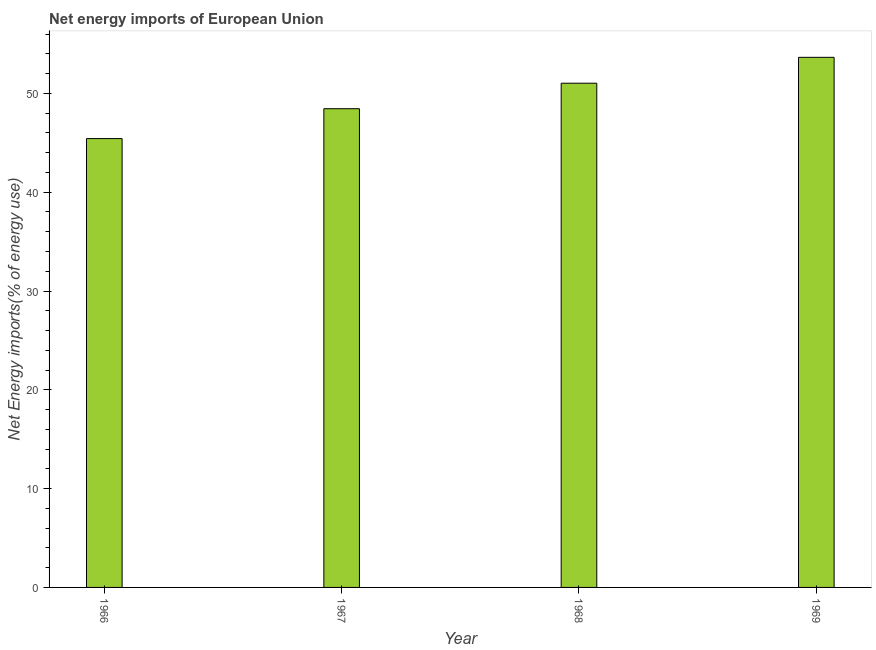What is the title of the graph?
Provide a short and direct response. Net energy imports of European Union. What is the label or title of the X-axis?
Your answer should be very brief. Year. What is the label or title of the Y-axis?
Keep it short and to the point. Net Energy imports(% of energy use). What is the energy imports in 1966?
Ensure brevity in your answer.  45.43. Across all years, what is the maximum energy imports?
Your answer should be very brief. 53.65. Across all years, what is the minimum energy imports?
Give a very brief answer. 45.43. In which year was the energy imports maximum?
Provide a succinct answer. 1969. In which year was the energy imports minimum?
Give a very brief answer. 1966. What is the sum of the energy imports?
Offer a terse response. 198.57. What is the difference between the energy imports in 1966 and 1968?
Your answer should be compact. -5.61. What is the average energy imports per year?
Your answer should be very brief. 49.64. What is the median energy imports?
Ensure brevity in your answer.  49.74. Do a majority of the years between 1966 and 1969 (inclusive) have energy imports greater than 32 %?
Your answer should be compact. Yes. What is the ratio of the energy imports in 1966 to that in 1967?
Give a very brief answer. 0.94. What is the difference between the highest and the second highest energy imports?
Your answer should be compact. 2.62. Is the sum of the energy imports in 1966 and 1967 greater than the maximum energy imports across all years?
Your response must be concise. Yes. What is the difference between the highest and the lowest energy imports?
Make the answer very short. 8.22. Are all the bars in the graph horizontal?
Offer a terse response. No. How many years are there in the graph?
Provide a short and direct response. 4. What is the difference between two consecutive major ticks on the Y-axis?
Your response must be concise. 10. Are the values on the major ticks of Y-axis written in scientific E-notation?
Give a very brief answer. No. What is the Net Energy imports(% of energy use) of 1966?
Give a very brief answer. 45.43. What is the Net Energy imports(% of energy use) in 1967?
Give a very brief answer. 48.45. What is the Net Energy imports(% of energy use) of 1968?
Your response must be concise. 51.03. What is the Net Energy imports(% of energy use) in 1969?
Keep it short and to the point. 53.65. What is the difference between the Net Energy imports(% of energy use) in 1966 and 1967?
Offer a very short reply. -3.02. What is the difference between the Net Energy imports(% of energy use) in 1966 and 1968?
Your response must be concise. -5.61. What is the difference between the Net Energy imports(% of energy use) in 1966 and 1969?
Your answer should be very brief. -8.22. What is the difference between the Net Energy imports(% of energy use) in 1967 and 1968?
Ensure brevity in your answer.  -2.58. What is the difference between the Net Energy imports(% of energy use) in 1967 and 1969?
Keep it short and to the point. -5.2. What is the difference between the Net Energy imports(% of energy use) in 1968 and 1969?
Your answer should be very brief. -2.62. What is the ratio of the Net Energy imports(% of energy use) in 1966 to that in 1967?
Your response must be concise. 0.94. What is the ratio of the Net Energy imports(% of energy use) in 1966 to that in 1968?
Keep it short and to the point. 0.89. What is the ratio of the Net Energy imports(% of energy use) in 1966 to that in 1969?
Offer a terse response. 0.85. What is the ratio of the Net Energy imports(% of energy use) in 1967 to that in 1968?
Keep it short and to the point. 0.95. What is the ratio of the Net Energy imports(% of energy use) in 1967 to that in 1969?
Make the answer very short. 0.9. What is the ratio of the Net Energy imports(% of energy use) in 1968 to that in 1969?
Make the answer very short. 0.95. 